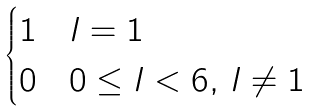<formula> <loc_0><loc_0><loc_500><loc_500>\begin{cases} 1 & l = 1 \\ 0 & 0 \leq l < 6 , \, l \neq 1 \end{cases}</formula> 